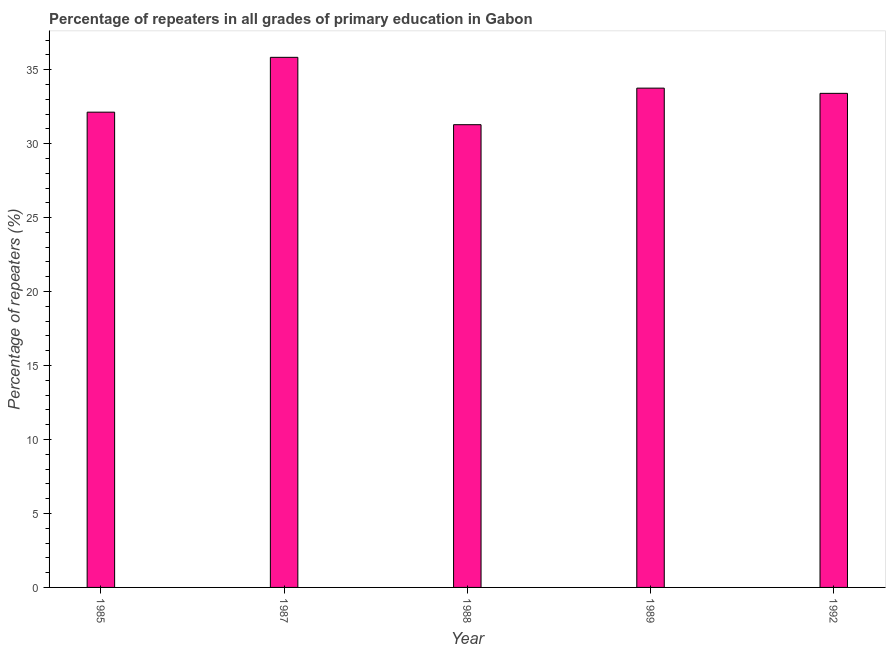What is the title of the graph?
Your answer should be very brief. Percentage of repeaters in all grades of primary education in Gabon. What is the label or title of the Y-axis?
Keep it short and to the point. Percentage of repeaters (%). What is the percentage of repeaters in primary education in 1989?
Provide a succinct answer. 33.75. Across all years, what is the maximum percentage of repeaters in primary education?
Your answer should be very brief. 35.83. Across all years, what is the minimum percentage of repeaters in primary education?
Your answer should be very brief. 31.28. In which year was the percentage of repeaters in primary education maximum?
Your answer should be very brief. 1987. What is the sum of the percentage of repeaters in primary education?
Make the answer very short. 166.4. What is the difference between the percentage of repeaters in primary education in 1988 and 1992?
Your answer should be very brief. -2.12. What is the average percentage of repeaters in primary education per year?
Keep it short and to the point. 33.28. What is the median percentage of repeaters in primary education?
Offer a very short reply. 33.4. In how many years, is the percentage of repeaters in primary education greater than 15 %?
Provide a short and direct response. 5. Do a majority of the years between 1992 and 1989 (inclusive) have percentage of repeaters in primary education greater than 30 %?
Offer a terse response. No. What is the ratio of the percentage of repeaters in primary education in 1987 to that in 1988?
Provide a short and direct response. 1.15. Is the percentage of repeaters in primary education in 1985 less than that in 1992?
Your answer should be very brief. Yes. Is the difference between the percentage of repeaters in primary education in 1985 and 1992 greater than the difference between any two years?
Keep it short and to the point. No. What is the difference between the highest and the second highest percentage of repeaters in primary education?
Your answer should be compact. 2.08. Is the sum of the percentage of repeaters in primary education in 1987 and 1988 greater than the maximum percentage of repeaters in primary education across all years?
Your answer should be compact. Yes. What is the difference between the highest and the lowest percentage of repeaters in primary education?
Keep it short and to the point. 4.55. How many bars are there?
Provide a short and direct response. 5. How many years are there in the graph?
Your answer should be compact. 5. Are the values on the major ticks of Y-axis written in scientific E-notation?
Give a very brief answer. No. What is the Percentage of repeaters (%) of 1985?
Provide a succinct answer. 32.13. What is the Percentage of repeaters (%) in 1987?
Your response must be concise. 35.83. What is the Percentage of repeaters (%) of 1988?
Keep it short and to the point. 31.28. What is the Percentage of repeaters (%) in 1989?
Give a very brief answer. 33.75. What is the Percentage of repeaters (%) in 1992?
Your response must be concise. 33.4. What is the difference between the Percentage of repeaters (%) in 1985 and 1987?
Your answer should be very brief. -3.71. What is the difference between the Percentage of repeaters (%) in 1985 and 1988?
Your answer should be very brief. 0.85. What is the difference between the Percentage of repeaters (%) in 1985 and 1989?
Give a very brief answer. -1.62. What is the difference between the Percentage of repeaters (%) in 1985 and 1992?
Your answer should be compact. -1.27. What is the difference between the Percentage of repeaters (%) in 1987 and 1988?
Provide a succinct answer. 4.55. What is the difference between the Percentage of repeaters (%) in 1987 and 1989?
Keep it short and to the point. 2.08. What is the difference between the Percentage of repeaters (%) in 1987 and 1992?
Ensure brevity in your answer.  2.43. What is the difference between the Percentage of repeaters (%) in 1988 and 1989?
Provide a succinct answer. -2.47. What is the difference between the Percentage of repeaters (%) in 1988 and 1992?
Provide a short and direct response. -2.12. What is the difference between the Percentage of repeaters (%) in 1989 and 1992?
Offer a very short reply. 0.35. What is the ratio of the Percentage of repeaters (%) in 1985 to that in 1987?
Ensure brevity in your answer.  0.9. What is the ratio of the Percentage of repeaters (%) in 1985 to that in 1989?
Ensure brevity in your answer.  0.95. What is the ratio of the Percentage of repeaters (%) in 1985 to that in 1992?
Your answer should be very brief. 0.96. What is the ratio of the Percentage of repeaters (%) in 1987 to that in 1988?
Provide a short and direct response. 1.15. What is the ratio of the Percentage of repeaters (%) in 1987 to that in 1989?
Make the answer very short. 1.06. What is the ratio of the Percentage of repeaters (%) in 1987 to that in 1992?
Provide a succinct answer. 1.07. What is the ratio of the Percentage of repeaters (%) in 1988 to that in 1989?
Offer a very short reply. 0.93. What is the ratio of the Percentage of repeaters (%) in 1988 to that in 1992?
Your answer should be very brief. 0.94. What is the ratio of the Percentage of repeaters (%) in 1989 to that in 1992?
Make the answer very short. 1.01. 